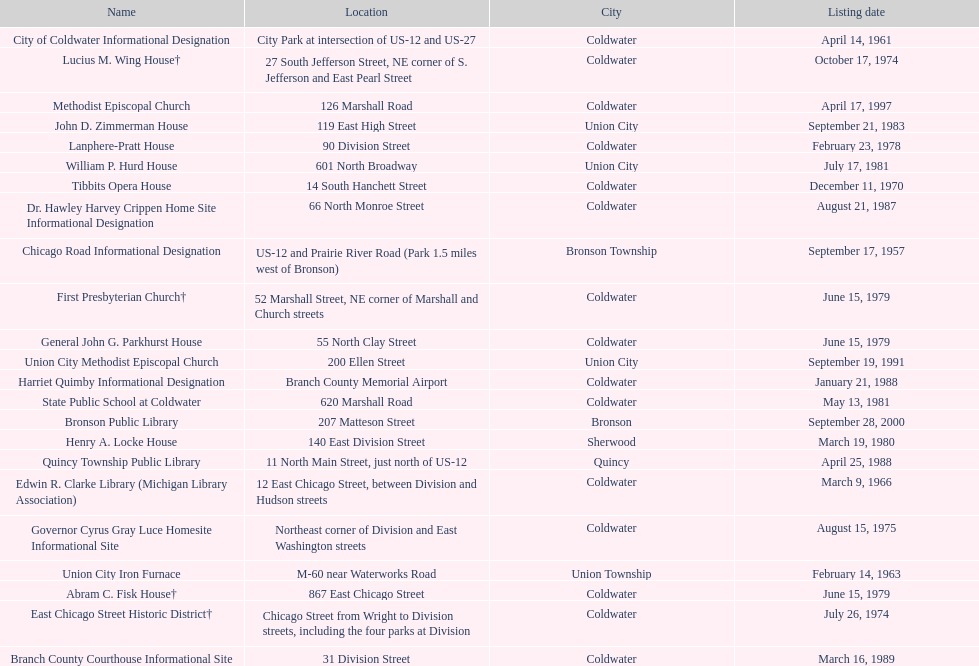Are there any listing dates that happened before 1960? September 17, 1957. What is the name of the site that was listed before 1960? Chicago Road Informational Designation. 